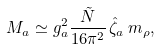<formula> <loc_0><loc_0><loc_500><loc_500>M _ { a } \simeq g _ { a } ^ { 2 } \frac { \tilde { N } } { 1 6 \pi ^ { 2 } } \, \hat { \zeta } _ { a } \, m _ { \rho } ,</formula> 